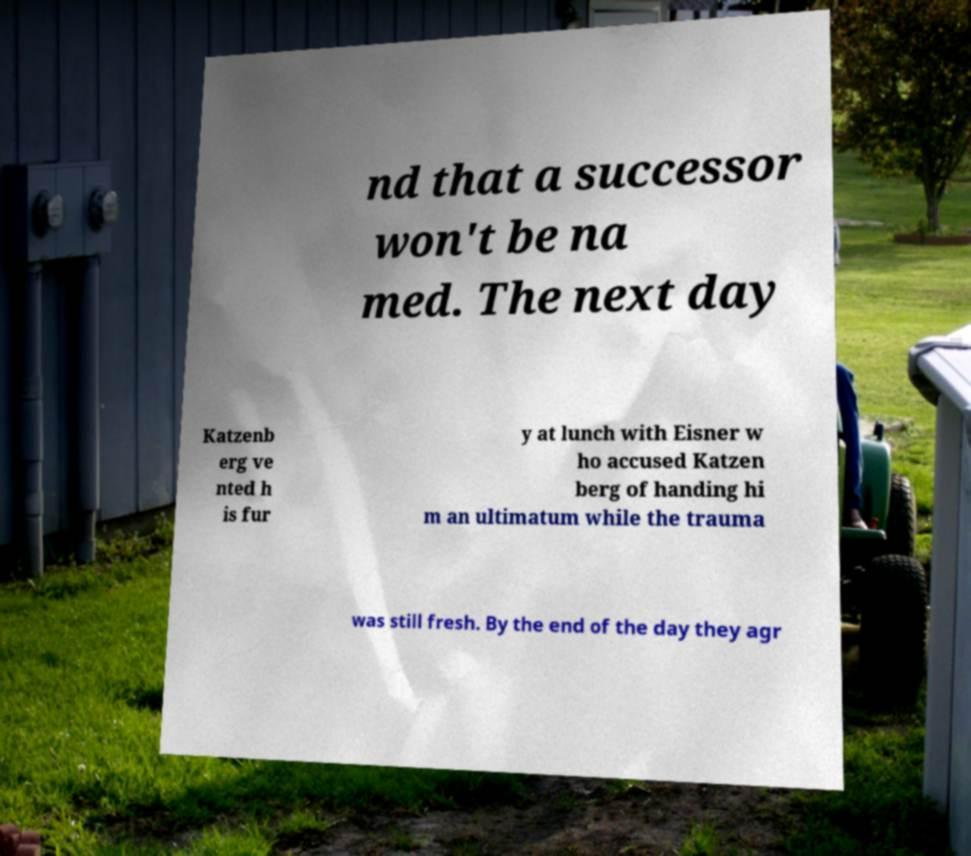Please identify and transcribe the text found in this image. nd that a successor won't be na med. The next day Katzenb erg ve nted h is fur y at lunch with Eisner w ho accused Katzen berg of handing hi m an ultimatum while the trauma was still fresh. By the end of the day they agr 